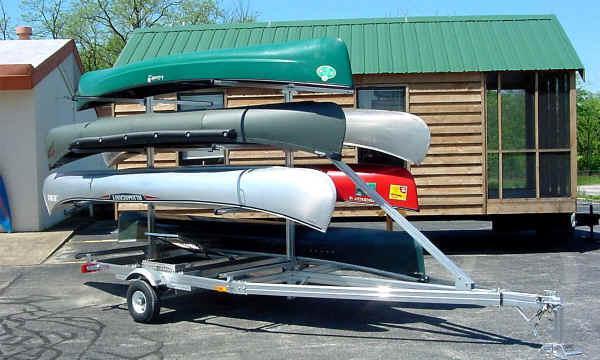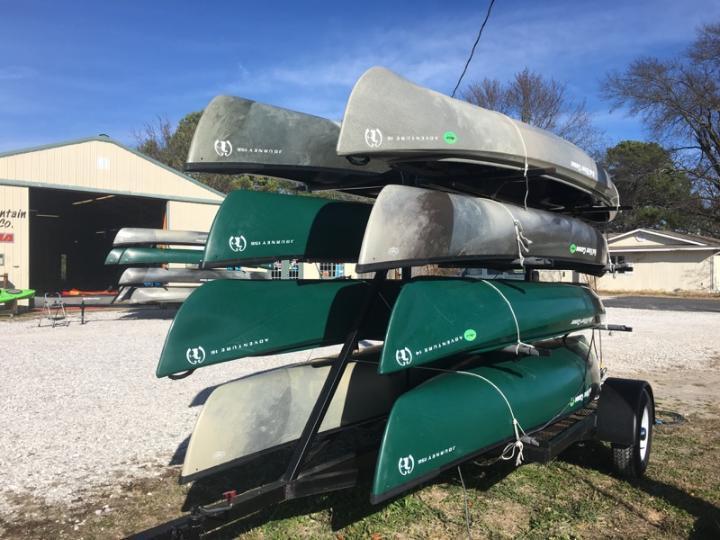The first image is the image on the left, the second image is the image on the right. Assess this claim about the two images: "In one of the pictures, the canoe is attached to the back of a car.". Correct or not? Answer yes or no. No. The first image is the image on the left, the second image is the image on the right. For the images shown, is this caption "There are at least four canoes loaded up to be transported elsewhere." true? Answer yes or no. Yes. 